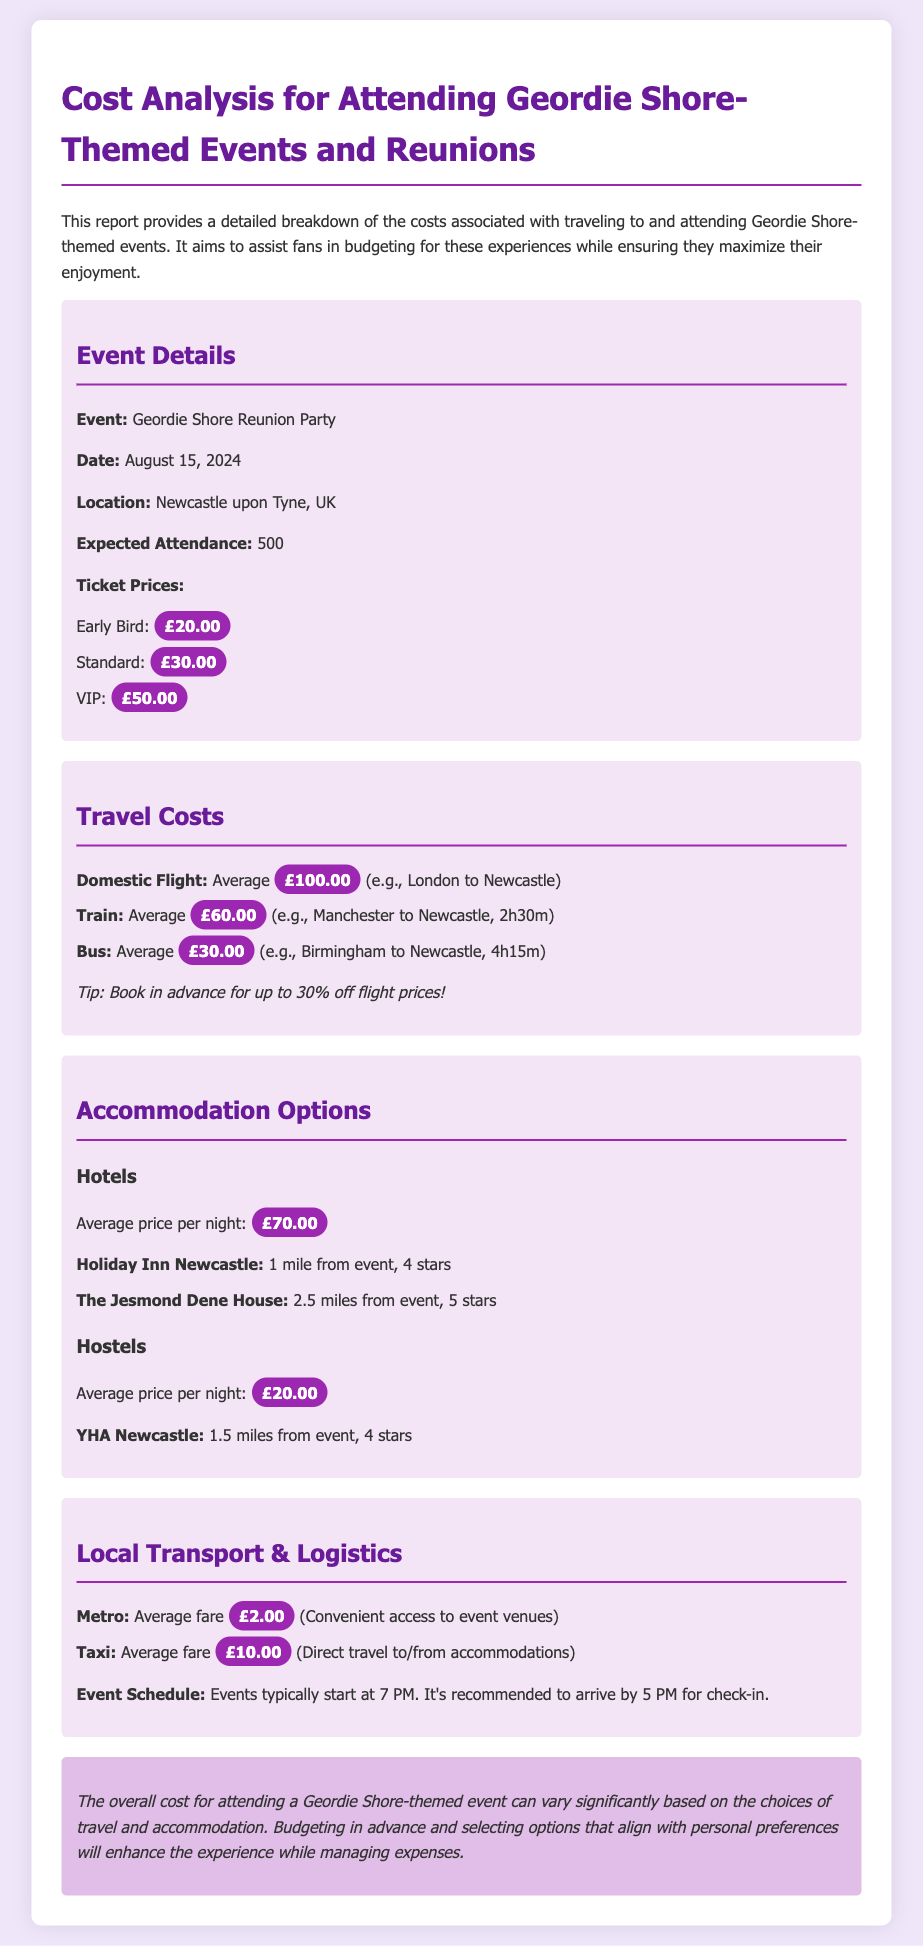What is the date of the event? The date of the event is specified in the event details section of the document.
Answer: August 15, 2024 What is the expected attendance? The expected attendance for the event is mentioned under event details.
Answer: 500 What is the price of the VIP ticket? The VIP ticket price is listed in the ticket pricing section of the document.
Answer: £50.00 What is the average price per night for hotels? The document states the average price for hotels in the accommodation section.
Answer: £70.00 What is the average fare for a taxi? The average fare for a taxi is provided in the local transport section.
Answer: £10.00 What are two types of transportation mentioned? The document lists several modes of travel; two are explicitly listed in the travel costs section.
Answer: Domestic Flight, Train If someone takes a bus from Birmingham to Newcastle, how long is the journey? The duration of the bus journey is detailed in the travel costs section.
Answer: 4h15m What is the average price for hostel accommodation? The average price for hostels is clearly stated in the accommodation options section.
Answer: £20.00 What is recommended for check-in before the event? The document suggests an arrival time to ensure timely check-in.
Answer: 5 PM 